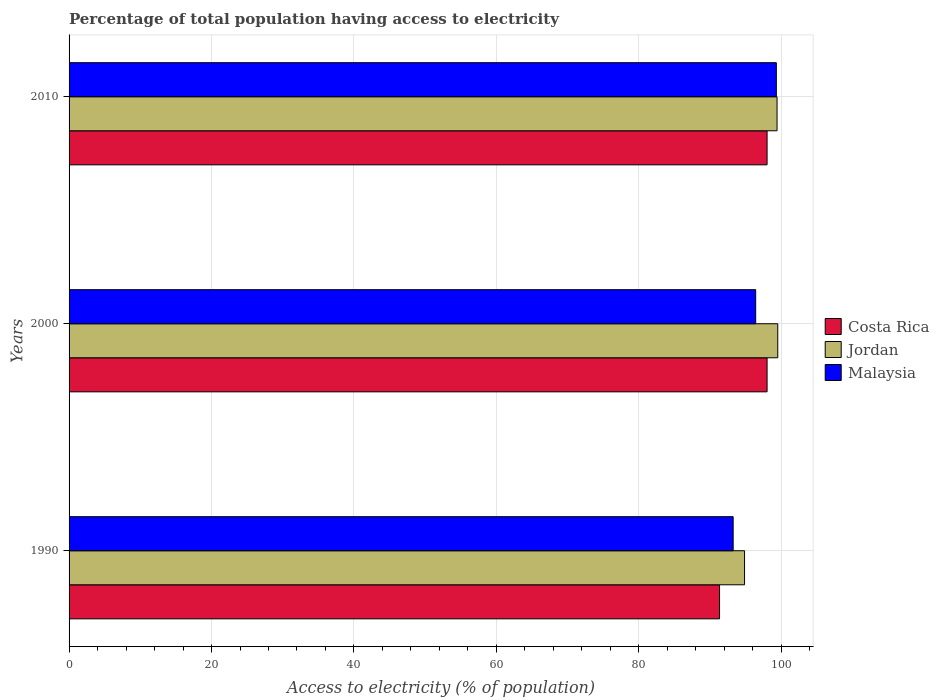Are the number of bars on each tick of the Y-axis equal?
Your answer should be very brief. Yes. How many bars are there on the 2nd tick from the bottom?
Give a very brief answer. 3. What is the percentage of population that have access to electricity in Malaysia in 2010?
Give a very brief answer. 99.3. Across all years, what is the minimum percentage of population that have access to electricity in Jordan?
Your answer should be compact. 94.84. In which year was the percentage of population that have access to electricity in Malaysia minimum?
Make the answer very short. 1990. What is the total percentage of population that have access to electricity in Jordan in the graph?
Offer a terse response. 293.74. What is the difference between the percentage of population that have access to electricity in Jordan in 1990 and the percentage of population that have access to electricity in Malaysia in 2010?
Your response must be concise. -4.46. What is the average percentage of population that have access to electricity in Jordan per year?
Your answer should be very brief. 97.91. In the year 2010, what is the difference between the percentage of population that have access to electricity in Jordan and percentage of population that have access to electricity in Costa Rica?
Provide a short and direct response. 1.4. Is the percentage of population that have access to electricity in Costa Rica in 2000 less than that in 2010?
Give a very brief answer. No. Is the difference between the percentage of population that have access to electricity in Jordan in 2000 and 2010 greater than the difference between the percentage of population that have access to electricity in Costa Rica in 2000 and 2010?
Keep it short and to the point. Yes. What is the difference between the highest and the second highest percentage of population that have access to electricity in Costa Rica?
Your answer should be compact. 0. What is the difference between the highest and the lowest percentage of population that have access to electricity in Malaysia?
Your answer should be compact. 6.06. Is the sum of the percentage of population that have access to electricity in Jordan in 2000 and 2010 greater than the maximum percentage of population that have access to electricity in Costa Rica across all years?
Your answer should be very brief. Yes. What does the 1st bar from the top in 2000 represents?
Make the answer very short. Malaysia. What does the 2nd bar from the bottom in 1990 represents?
Your answer should be very brief. Jordan. How many bars are there?
Your answer should be compact. 9. Are the values on the major ticks of X-axis written in scientific E-notation?
Your answer should be very brief. No. Does the graph contain any zero values?
Provide a succinct answer. No. How are the legend labels stacked?
Provide a succinct answer. Vertical. What is the title of the graph?
Offer a very short reply. Percentage of total population having access to electricity. Does "Central Europe" appear as one of the legend labels in the graph?
Your answer should be very brief. No. What is the label or title of the X-axis?
Ensure brevity in your answer.  Access to electricity (% of population). What is the label or title of the Y-axis?
Offer a very short reply. Years. What is the Access to electricity (% of population) in Costa Rica in 1990?
Give a very brief answer. 91.33. What is the Access to electricity (% of population) of Jordan in 1990?
Make the answer very short. 94.84. What is the Access to electricity (% of population) in Malaysia in 1990?
Keep it short and to the point. 93.24. What is the Access to electricity (% of population) in Jordan in 2000?
Give a very brief answer. 99.5. What is the Access to electricity (% of population) in Malaysia in 2000?
Your answer should be compact. 96.4. What is the Access to electricity (% of population) of Jordan in 2010?
Keep it short and to the point. 99.4. What is the Access to electricity (% of population) in Malaysia in 2010?
Offer a very short reply. 99.3. Across all years, what is the maximum Access to electricity (% of population) of Costa Rica?
Keep it short and to the point. 98. Across all years, what is the maximum Access to electricity (% of population) of Jordan?
Keep it short and to the point. 99.5. Across all years, what is the maximum Access to electricity (% of population) of Malaysia?
Give a very brief answer. 99.3. Across all years, what is the minimum Access to electricity (% of population) of Costa Rica?
Your answer should be very brief. 91.33. Across all years, what is the minimum Access to electricity (% of population) of Jordan?
Keep it short and to the point. 94.84. Across all years, what is the minimum Access to electricity (% of population) in Malaysia?
Your response must be concise. 93.24. What is the total Access to electricity (% of population) of Costa Rica in the graph?
Give a very brief answer. 287.33. What is the total Access to electricity (% of population) in Jordan in the graph?
Ensure brevity in your answer.  293.74. What is the total Access to electricity (% of population) in Malaysia in the graph?
Your response must be concise. 288.94. What is the difference between the Access to electricity (% of population) in Costa Rica in 1990 and that in 2000?
Your answer should be compact. -6.67. What is the difference between the Access to electricity (% of population) of Jordan in 1990 and that in 2000?
Your answer should be compact. -4.66. What is the difference between the Access to electricity (% of population) in Malaysia in 1990 and that in 2000?
Offer a terse response. -3.16. What is the difference between the Access to electricity (% of population) of Costa Rica in 1990 and that in 2010?
Your answer should be compact. -6.67. What is the difference between the Access to electricity (% of population) in Jordan in 1990 and that in 2010?
Offer a terse response. -4.56. What is the difference between the Access to electricity (% of population) in Malaysia in 1990 and that in 2010?
Offer a terse response. -6.06. What is the difference between the Access to electricity (% of population) of Jordan in 2000 and that in 2010?
Your response must be concise. 0.1. What is the difference between the Access to electricity (% of population) of Costa Rica in 1990 and the Access to electricity (% of population) of Jordan in 2000?
Your answer should be very brief. -8.17. What is the difference between the Access to electricity (% of population) of Costa Rica in 1990 and the Access to electricity (% of population) of Malaysia in 2000?
Give a very brief answer. -5.07. What is the difference between the Access to electricity (% of population) of Jordan in 1990 and the Access to electricity (% of population) of Malaysia in 2000?
Give a very brief answer. -1.56. What is the difference between the Access to electricity (% of population) in Costa Rica in 1990 and the Access to electricity (% of population) in Jordan in 2010?
Offer a very short reply. -8.07. What is the difference between the Access to electricity (% of population) of Costa Rica in 1990 and the Access to electricity (% of population) of Malaysia in 2010?
Make the answer very short. -7.97. What is the difference between the Access to electricity (% of population) of Jordan in 1990 and the Access to electricity (% of population) of Malaysia in 2010?
Provide a succinct answer. -4.46. What is the difference between the Access to electricity (% of population) in Costa Rica in 2000 and the Access to electricity (% of population) in Jordan in 2010?
Make the answer very short. -1.4. What is the difference between the Access to electricity (% of population) of Costa Rica in 2000 and the Access to electricity (% of population) of Malaysia in 2010?
Provide a succinct answer. -1.3. What is the difference between the Access to electricity (% of population) in Jordan in 2000 and the Access to electricity (% of population) in Malaysia in 2010?
Offer a very short reply. 0.2. What is the average Access to electricity (% of population) of Costa Rica per year?
Give a very brief answer. 95.78. What is the average Access to electricity (% of population) of Jordan per year?
Offer a very short reply. 97.91. What is the average Access to electricity (% of population) in Malaysia per year?
Give a very brief answer. 96.31. In the year 1990, what is the difference between the Access to electricity (% of population) in Costa Rica and Access to electricity (% of population) in Jordan?
Make the answer very short. -3.51. In the year 1990, what is the difference between the Access to electricity (% of population) of Costa Rica and Access to electricity (% of population) of Malaysia?
Keep it short and to the point. -1.91. In the year 1990, what is the difference between the Access to electricity (% of population) of Jordan and Access to electricity (% of population) of Malaysia?
Keep it short and to the point. 1.6. In the year 2000, what is the difference between the Access to electricity (% of population) in Costa Rica and Access to electricity (% of population) in Jordan?
Your answer should be compact. -1.5. In the year 2000, what is the difference between the Access to electricity (% of population) of Costa Rica and Access to electricity (% of population) of Malaysia?
Ensure brevity in your answer.  1.6. In the year 2000, what is the difference between the Access to electricity (% of population) in Jordan and Access to electricity (% of population) in Malaysia?
Your answer should be compact. 3.1. In the year 2010, what is the difference between the Access to electricity (% of population) of Costa Rica and Access to electricity (% of population) of Jordan?
Ensure brevity in your answer.  -1.4. In the year 2010, what is the difference between the Access to electricity (% of population) in Costa Rica and Access to electricity (% of population) in Malaysia?
Offer a terse response. -1.3. What is the ratio of the Access to electricity (% of population) of Costa Rica in 1990 to that in 2000?
Your answer should be compact. 0.93. What is the ratio of the Access to electricity (% of population) in Jordan in 1990 to that in 2000?
Provide a succinct answer. 0.95. What is the ratio of the Access to electricity (% of population) in Malaysia in 1990 to that in 2000?
Your response must be concise. 0.97. What is the ratio of the Access to electricity (% of population) of Costa Rica in 1990 to that in 2010?
Give a very brief answer. 0.93. What is the ratio of the Access to electricity (% of population) in Jordan in 1990 to that in 2010?
Ensure brevity in your answer.  0.95. What is the ratio of the Access to electricity (% of population) in Malaysia in 1990 to that in 2010?
Offer a terse response. 0.94. What is the ratio of the Access to electricity (% of population) in Malaysia in 2000 to that in 2010?
Make the answer very short. 0.97. What is the difference between the highest and the second highest Access to electricity (% of population) of Costa Rica?
Offer a terse response. 0. What is the difference between the highest and the second highest Access to electricity (% of population) of Malaysia?
Your response must be concise. 2.9. What is the difference between the highest and the lowest Access to electricity (% of population) of Costa Rica?
Give a very brief answer. 6.67. What is the difference between the highest and the lowest Access to electricity (% of population) of Jordan?
Make the answer very short. 4.66. What is the difference between the highest and the lowest Access to electricity (% of population) of Malaysia?
Keep it short and to the point. 6.06. 